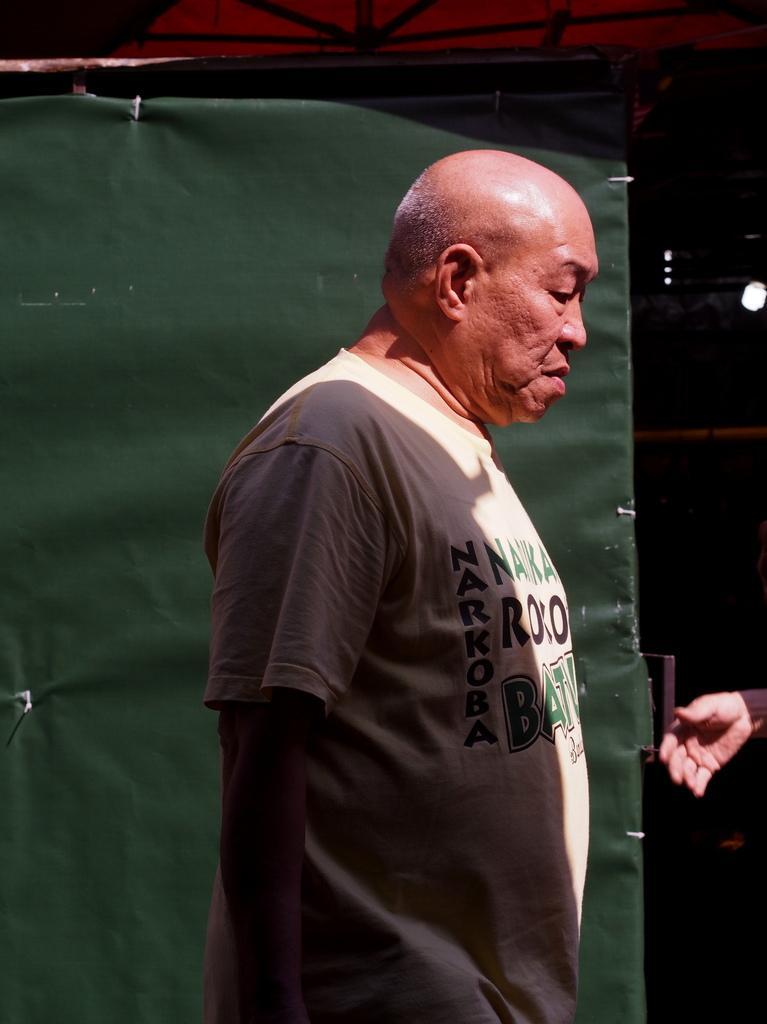What is the main subject of the image? There is a person standing in the image. What color is the object in the image? There is a green color object in the image. Can you describe any specific body part of the person in the image? A person's hand is visible in the image. What can be observed about the overall lighting or color of the image? The background of the image is dark. What type of bear can be seen interacting with the person in the image? There is no bear present in the image; it only features a person standing. How much wealth does the person in the image possess? The image does not provide any information about the person's wealth. 